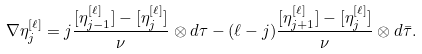<formula> <loc_0><loc_0><loc_500><loc_500>\nabla \eta ^ { [ \ell ] } _ { j } = j \frac { [ \eta _ { j - 1 } ^ { [ \ell ] } ] - [ \eta ^ { [ \ell ] } _ { j } ] } { \nu } \otimes d \tau - ( \ell - j ) \frac { [ \eta _ { j + 1 } ^ { [ \ell ] } ] - [ \eta _ { j } ^ { [ \ell ] } ] } { \nu } \otimes d \bar { \tau } . \\</formula> 